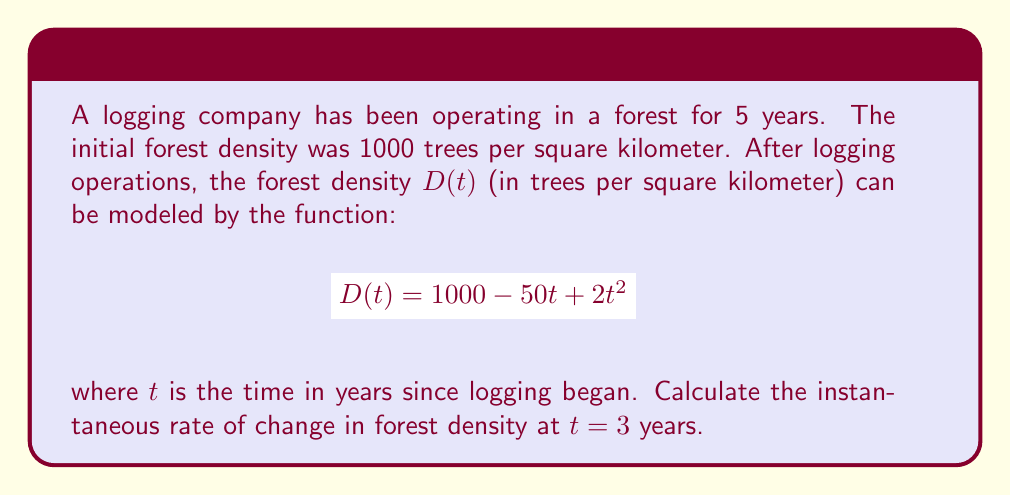Show me your answer to this math problem. To find the instantaneous rate of change in forest density at $t = 3$ years, we need to calculate the derivative of the function $D(t)$ and evaluate it at $t = 3$.

1. Given function: $D(t) = 1000 - 50t + 2t^2$

2. Calculate the derivative:
   $$\frac{d}{dt}D(t) = \frac{d}{dt}(1000 - 50t + 2t^2)$$
   $$D'(t) = 0 - 50 + 4t$$
   $$D'(t) = 4t - 50$$

3. Evaluate the derivative at $t = 3$:
   $$D'(3) = 4(3) - 50$$
   $$D'(3) = 12 - 50$$
   $$D'(3) = -38$$

The negative value indicates that the forest density is decreasing at this point in time. The units are trees per square kilometer per year.
Answer: The instantaneous rate of change in forest density at $t = 3$ years is $-38$ trees per square kilometer per year. 